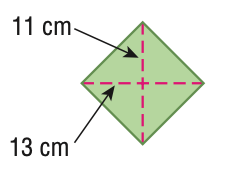Answer the mathemtical geometry problem and directly provide the correct option letter.
Question: Find the area of the figure. Round to the nearest tenth if necessary.
Choices: A: 48 B: 143 C: 286 D: 572 C 